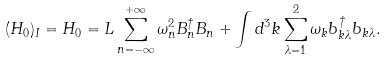<formula> <loc_0><loc_0><loc_500><loc_500>( H _ { 0 } ) _ { I } = H _ { 0 } = L \sum _ { n = - \infty } ^ { + \infty } \omega _ { n } ^ { 2 } B _ { n } ^ { \dag } B _ { n } + \int d ^ { 3 } k \sum _ { \lambda = 1 } ^ { 2 } \omega _ { k } b _ { k \lambda } ^ { \dag } b _ { k \lambda } .</formula> 